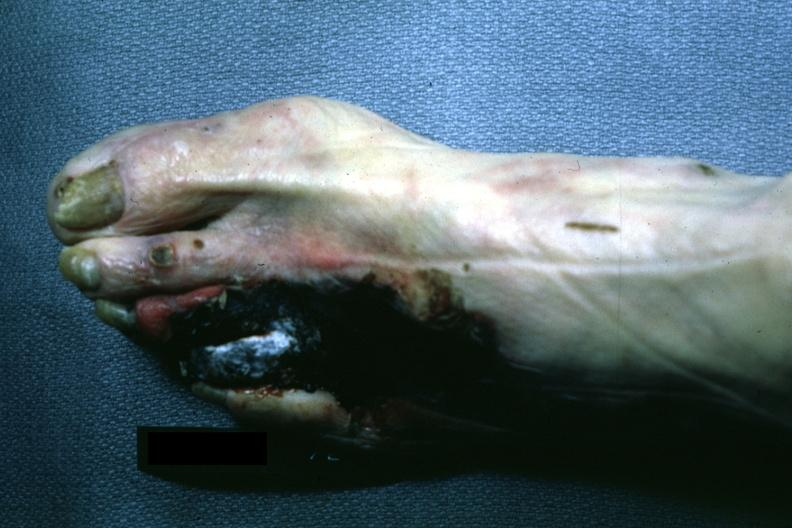what are present?
Answer the question using a single word or phrase. Extremities 